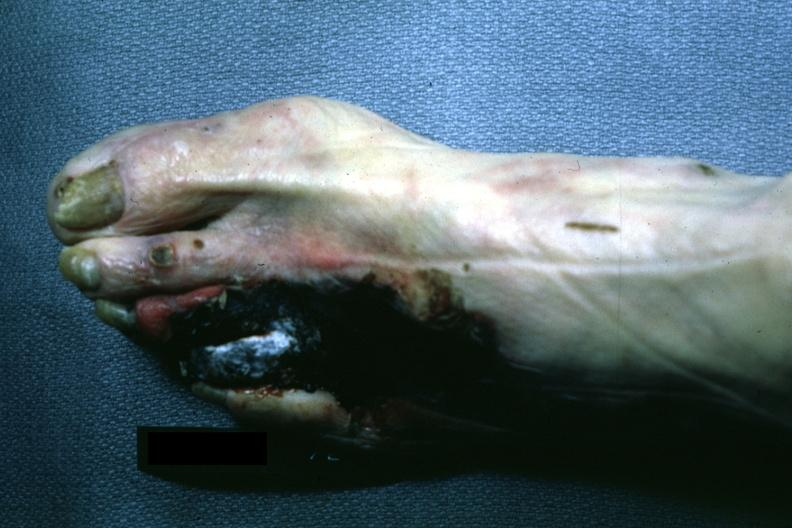what are present?
Answer the question using a single word or phrase. Extremities 